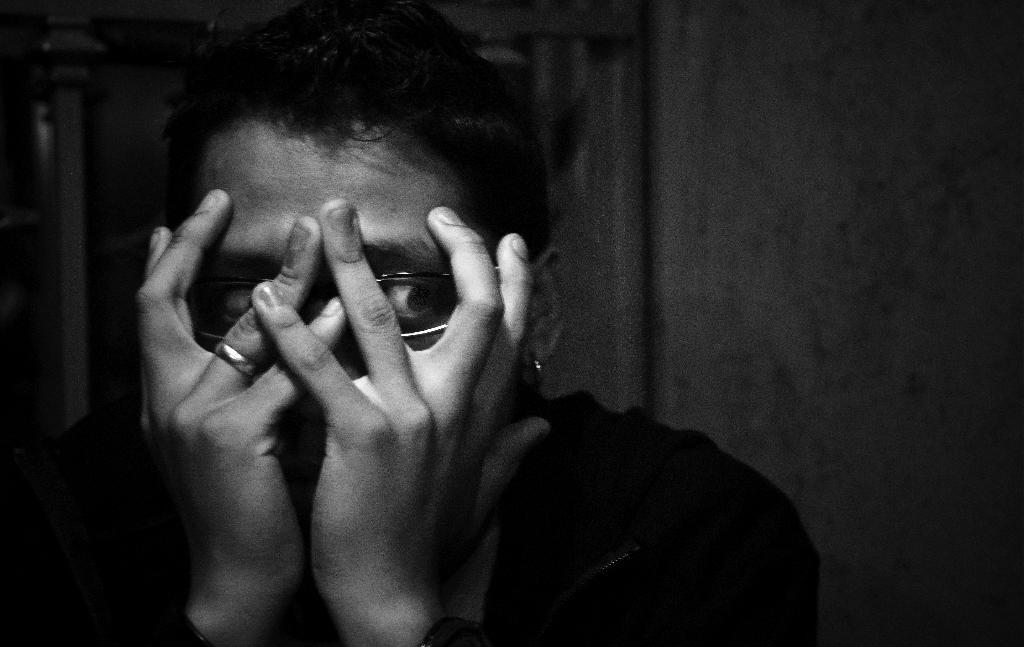What is the main subject of the image? There is a person in the image. What color scheme is used in the image? The image is in black and white. What type of brick is being used to soothe the person's throat in the image? There is no brick or reference to a throat in the image; it only features a person in black and white. 